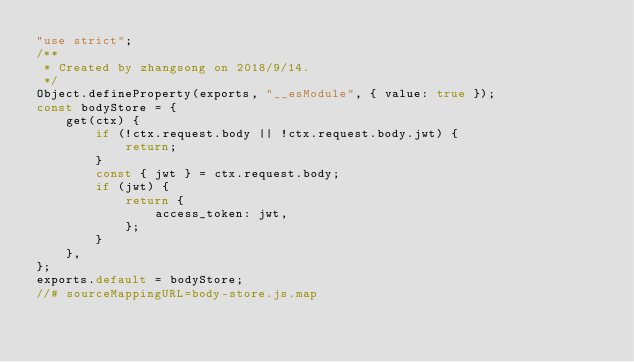<code> <loc_0><loc_0><loc_500><loc_500><_JavaScript_>"use strict";
/**
 * Created by zhangsong on 2018/9/14.
 */
Object.defineProperty(exports, "__esModule", { value: true });
const bodyStore = {
    get(ctx) {
        if (!ctx.request.body || !ctx.request.body.jwt) {
            return;
        }
        const { jwt } = ctx.request.body;
        if (jwt) {
            return {
                access_token: jwt,
            };
        }
    },
};
exports.default = bodyStore;
//# sourceMappingURL=body-store.js.map</code> 